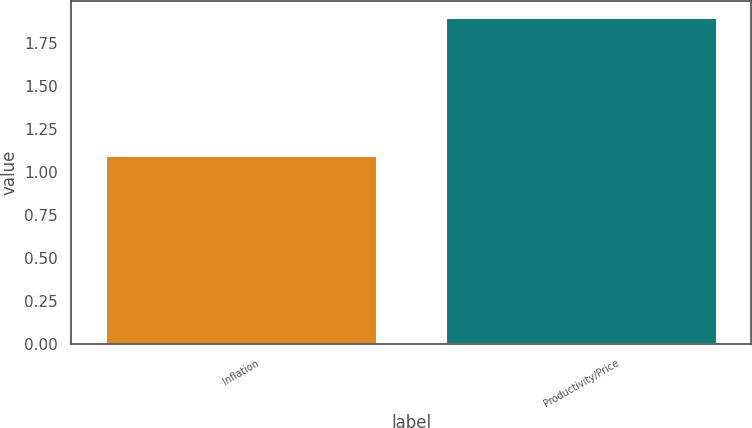Convert chart. <chart><loc_0><loc_0><loc_500><loc_500><bar_chart><fcel>Inflation<fcel>Productivity/Price<nl><fcel>1.1<fcel>1.9<nl></chart> 